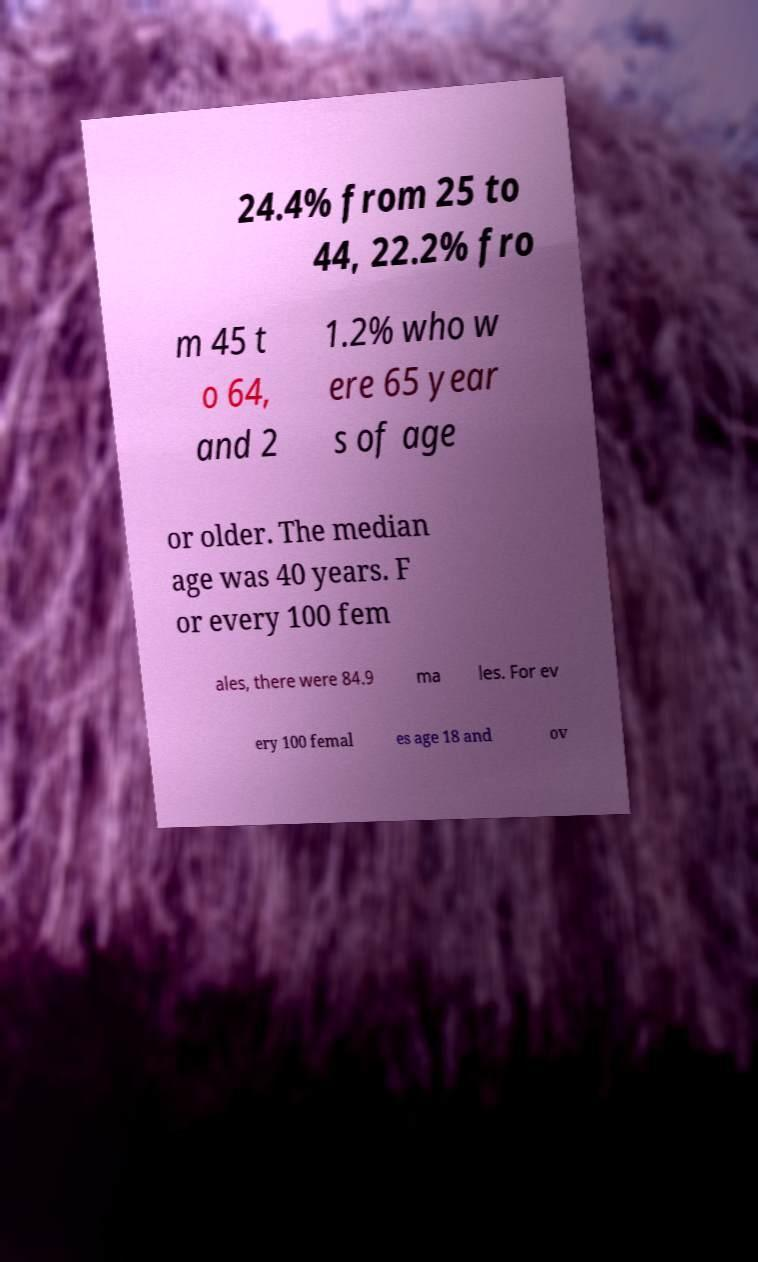Please identify and transcribe the text found in this image. 24.4% from 25 to 44, 22.2% fro m 45 t o 64, and 2 1.2% who w ere 65 year s of age or older. The median age was 40 years. F or every 100 fem ales, there were 84.9 ma les. For ev ery 100 femal es age 18 and ov 